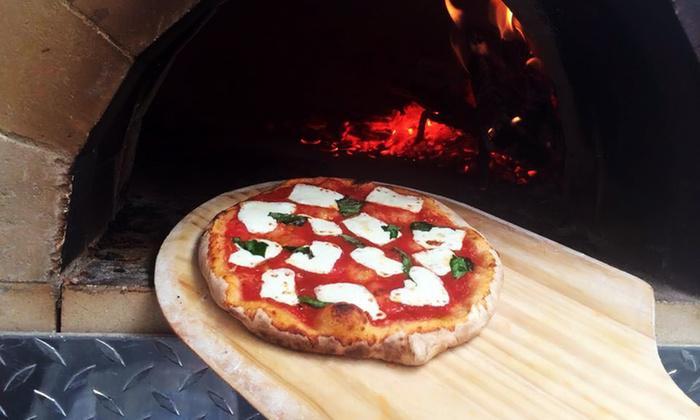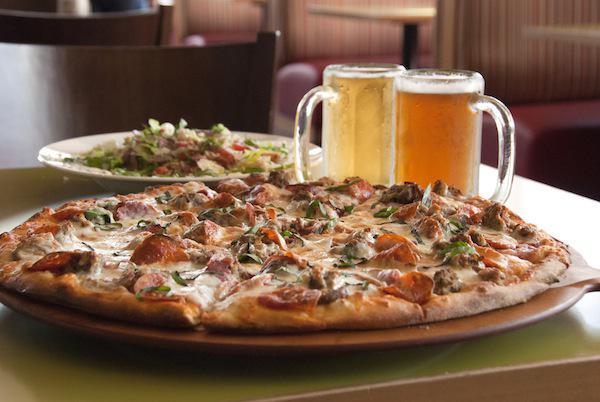The first image is the image on the left, the second image is the image on the right. For the images displayed, is the sentence "In the image on the right, there is at least one full mug of beer sitting on the table to the right of the pizza." factually correct? Answer yes or no. Yes. The first image is the image on the left, the second image is the image on the right. Examine the images to the left and right. Is the description "The right image includes a filled glass of amber beer with foam on top, behind a round pizza with a thin crust." accurate? Answer yes or no. Yes. 